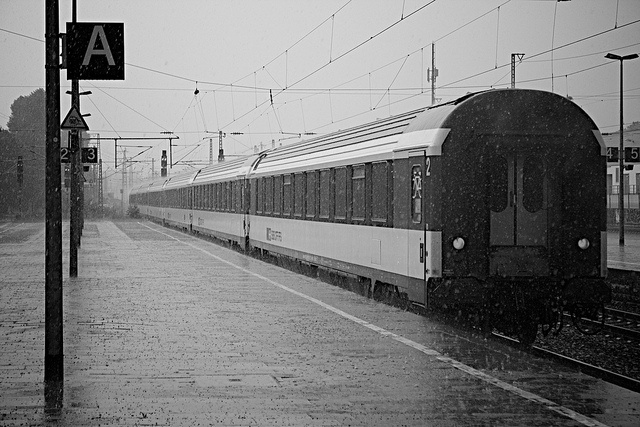Describe the objects in this image and their specific colors. I can see a train in darkgray, black, gray, and lightgray tones in this image. 